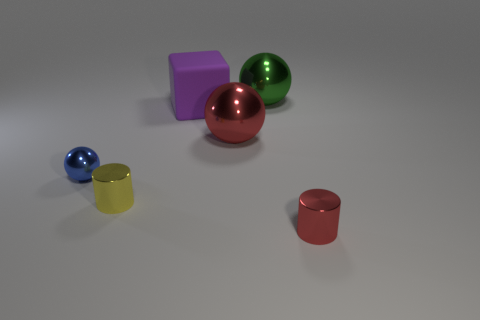There is a block that is the same size as the green sphere; what color is it?
Provide a succinct answer. Purple. What number of things are either large shiny things in front of the cube or yellow shiny cylinders?
Offer a terse response. 2. There is a cylinder behind the red thing in front of the tiny blue thing; what is it made of?
Your answer should be compact. Metal. Are there any brown cubes that have the same material as the tiny ball?
Your answer should be compact. No. There is a small thing that is left of the tiny yellow cylinder; is there a blue ball that is to the right of it?
Your answer should be compact. No. What is the material of the big ball that is in front of the purple rubber cube?
Make the answer very short. Metal. Is the shape of the big red thing the same as the green shiny thing?
Make the answer very short. Yes. There is a small metallic cylinder that is behind the red metal thing in front of the metallic cylinder on the left side of the green object; what is its color?
Your response must be concise. Yellow. How many large green metal things have the same shape as the purple rubber object?
Give a very brief answer. 0. What size is the red shiny object that is behind the cylinder that is left of the large purple object?
Ensure brevity in your answer.  Large. 